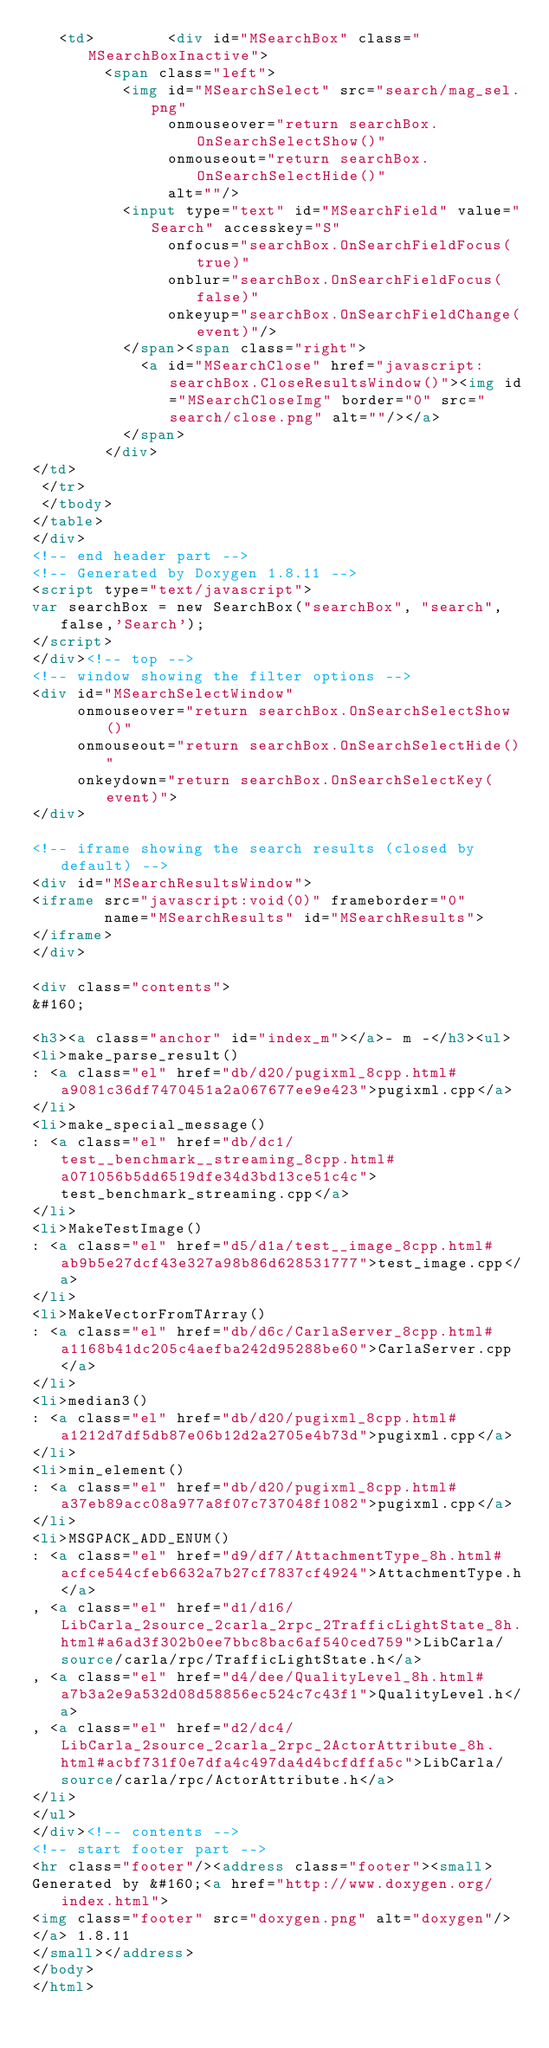Convert code to text. <code><loc_0><loc_0><loc_500><loc_500><_HTML_>   <td>        <div id="MSearchBox" class="MSearchBoxInactive">
        <span class="left">
          <img id="MSearchSelect" src="search/mag_sel.png"
               onmouseover="return searchBox.OnSearchSelectShow()"
               onmouseout="return searchBox.OnSearchSelectHide()"
               alt=""/>
          <input type="text" id="MSearchField" value="Search" accesskey="S"
               onfocus="searchBox.OnSearchFieldFocus(true)" 
               onblur="searchBox.OnSearchFieldFocus(false)" 
               onkeyup="searchBox.OnSearchFieldChange(event)"/>
          </span><span class="right">
            <a id="MSearchClose" href="javascript:searchBox.CloseResultsWindow()"><img id="MSearchCloseImg" border="0" src="search/close.png" alt=""/></a>
          </span>
        </div>
</td>
 </tr>
 </tbody>
</table>
</div>
<!-- end header part -->
<!-- Generated by Doxygen 1.8.11 -->
<script type="text/javascript">
var searchBox = new SearchBox("searchBox", "search",false,'Search');
</script>
</div><!-- top -->
<!-- window showing the filter options -->
<div id="MSearchSelectWindow"
     onmouseover="return searchBox.OnSearchSelectShow()"
     onmouseout="return searchBox.OnSearchSelectHide()"
     onkeydown="return searchBox.OnSearchSelectKey(event)">
</div>

<!-- iframe showing the search results (closed by default) -->
<div id="MSearchResultsWindow">
<iframe src="javascript:void(0)" frameborder="0" 
        name="MSearchResults" id="MSearchResults">
</iframe>
</div>

<div class="contents">
&#160;

<h3><a class="anchor" id="index_m"></a>- m -</h3><ul>
<li>make_parse_result()
: <a class="el" href="db/d20/pugixml_8cpp.html#a9081c36df7470451a2a067677ee9e423">pugixml.cpp</a>
</li>
<li>make_special_message()
: <a class="el" href="db/dc1/test__benchmark__streaming_8cpp.html#a071056b5dd6519dfe34d3bd13ce51c4c">test_benchmark_streaming.cpp</a>
</li>
<li>MakeTestImage()
: <a class="el" href="d5/d1a/test__image_8cpp.html#ab9b5e27dcf43e327a98b86d628531777">test_image.cpp</a>
</li>
<li>MakeVectorFromTArray()
: <a class="el" href="db/d6c/CarlaServer_8cpp.html#a1168b41dc205c4aefba242d95288be60">CarlaServer.cpp</a>
</li>
<li>median3()
: <a class="el" href="db/d20/pugixml_8cpp.html#a1212d7df5db87e06b12d2a2705e4b73d">pugixml.cpp</a>
</li>
<li>min_element()
: <a class="el" href="db/d20/pugixml_8cpp.html#a37eb89acc08a977a8f07c737048f1082">pugixml.cpp</a>
</li>
<li>MSGPACK_ADD_ENUM()
: <a class="el" href="d9/df7/AttachmentType_8h.html#acfce544cfeb6632a7b27cf7837cf4924">AttachmentType.h</a>
, <a class="el" href="d1/d16/LibCarla_2source_2carla_2rpc_2TrafficLightState_8h.html#a6ad3f302b0ee7bbc8bac6af540ced759">LibCarla/source/carla/rpc/TrafficLightState.h</a>
, <a class="el" href="d4/dee/QualityLevel_8h.html#a7b3a2e9a532d08d58856ec524c7c43f1">QualityLevel.h</a>
, <a class="el" href="d2/dc4/LibCarla_2source_2carla_2rpc_2ActorAttribute_8h.html#acbf731f0e7dfa4c497da4d4bcfdffa5c">LibCarla/source/carla/rpc/ActorAttribute.h</a>
</li>
</ul>
</div><!-- contents -->
<!-- start footer part -->
<hr class="footer"/><address class="footer"><small>
Generated by &#160;<a href="http://www.doxygen.org/index.html">
<img class="footer" src="doxygen.png" alt="doxygen"/>
</a> 1.8.11
</small></address>
</body>
</html>
</code> 